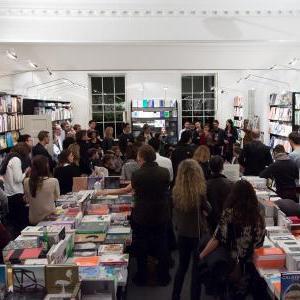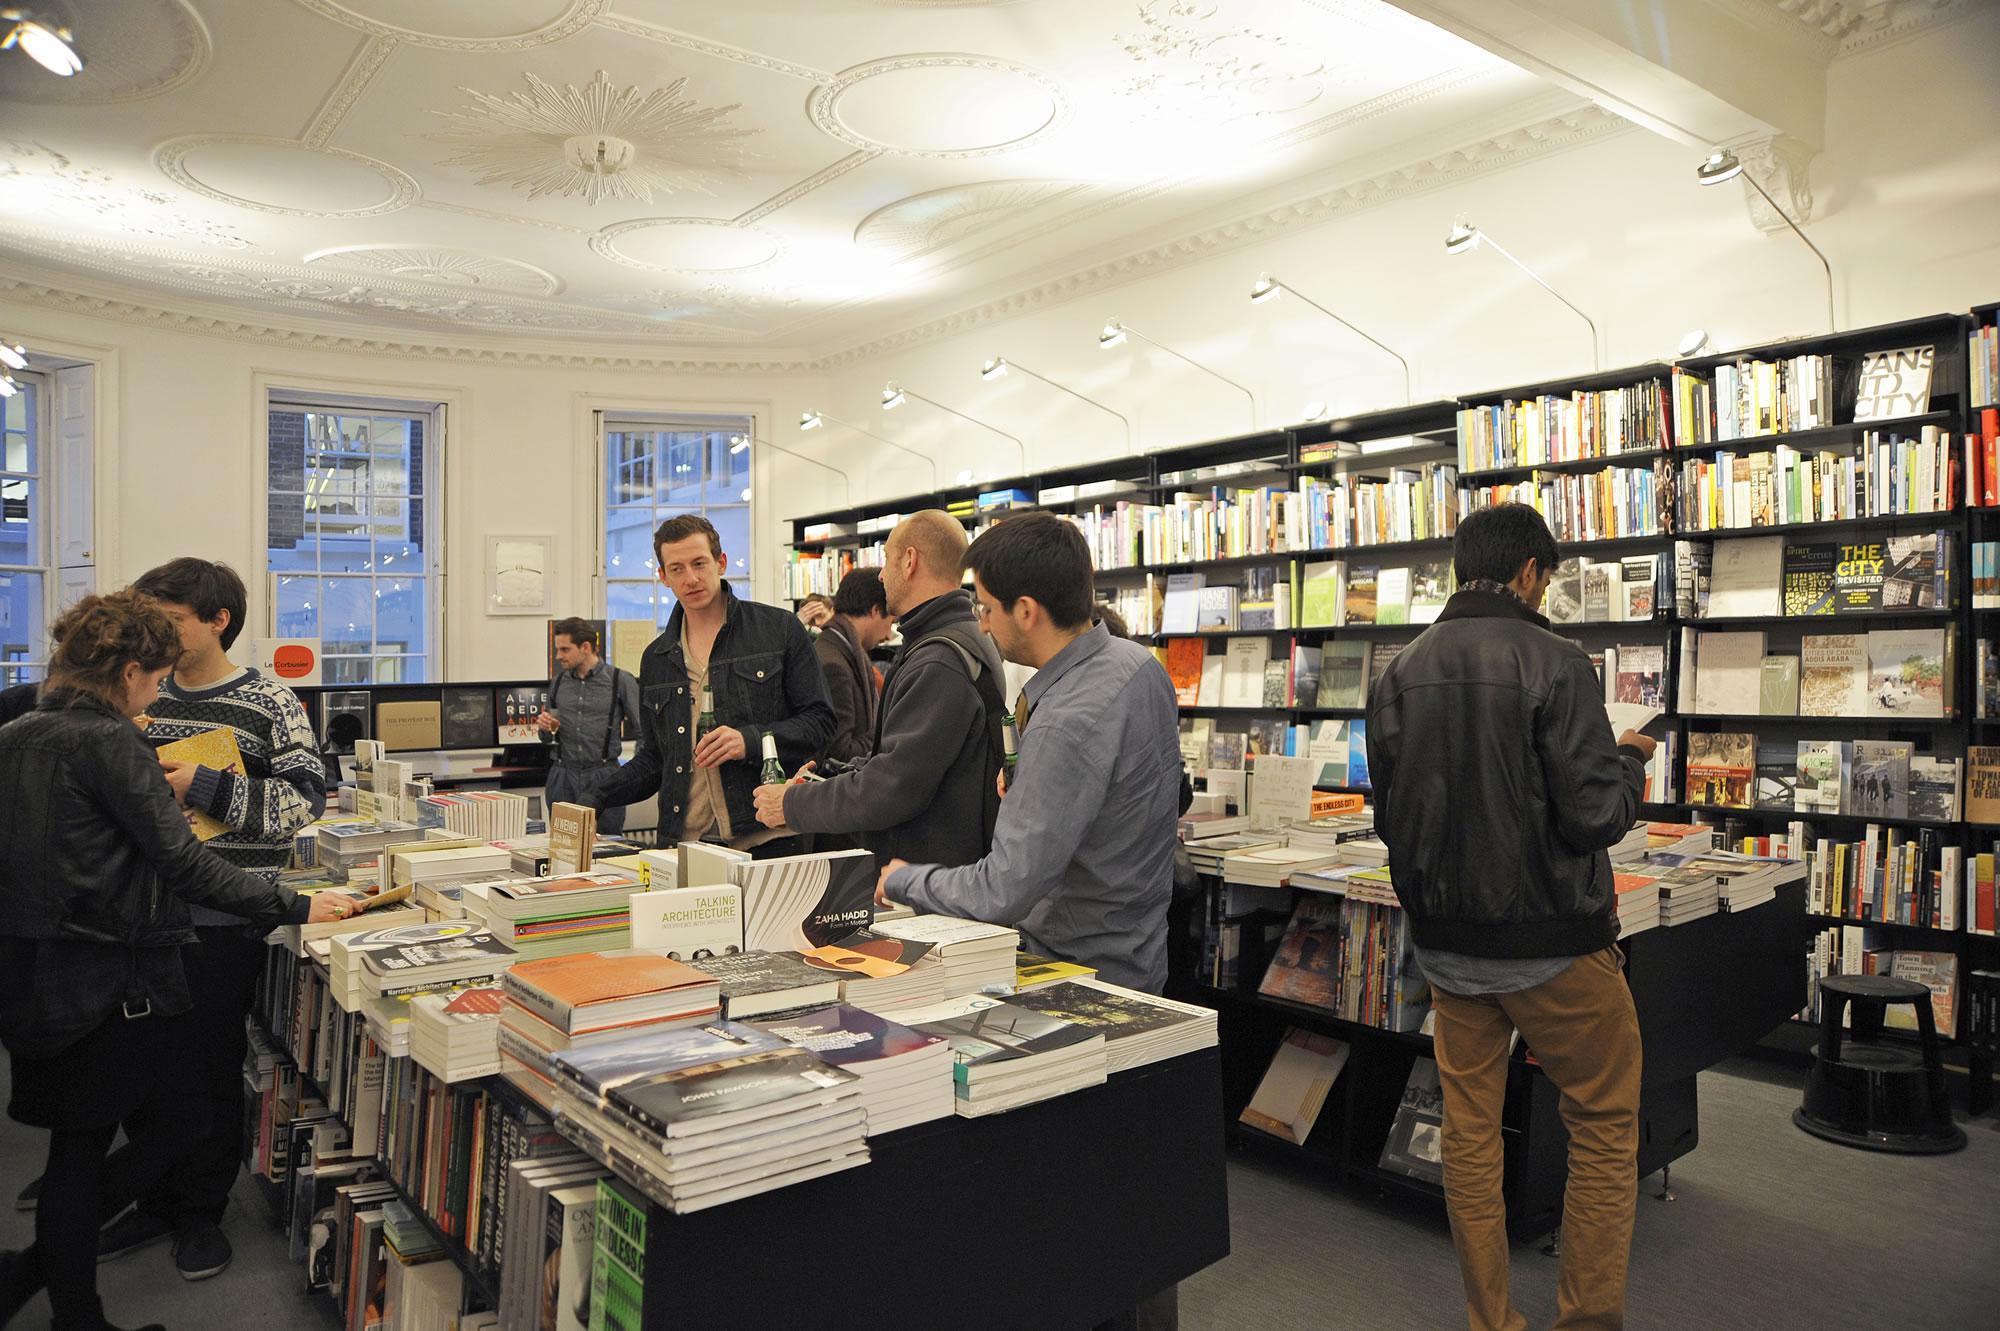The first image is the image on the left, the second image is the image on the right. For the images shown, is this caption "In one of the images there is a bookstore without any shoppers." true? Answer yes or no. No. The first image is the image on the left, the second image is the image on the right. For the images shown, is this caption "In one image, four rows of books are on shelves high over the heads of people on the floor below." true? Answer yes or no. No. 